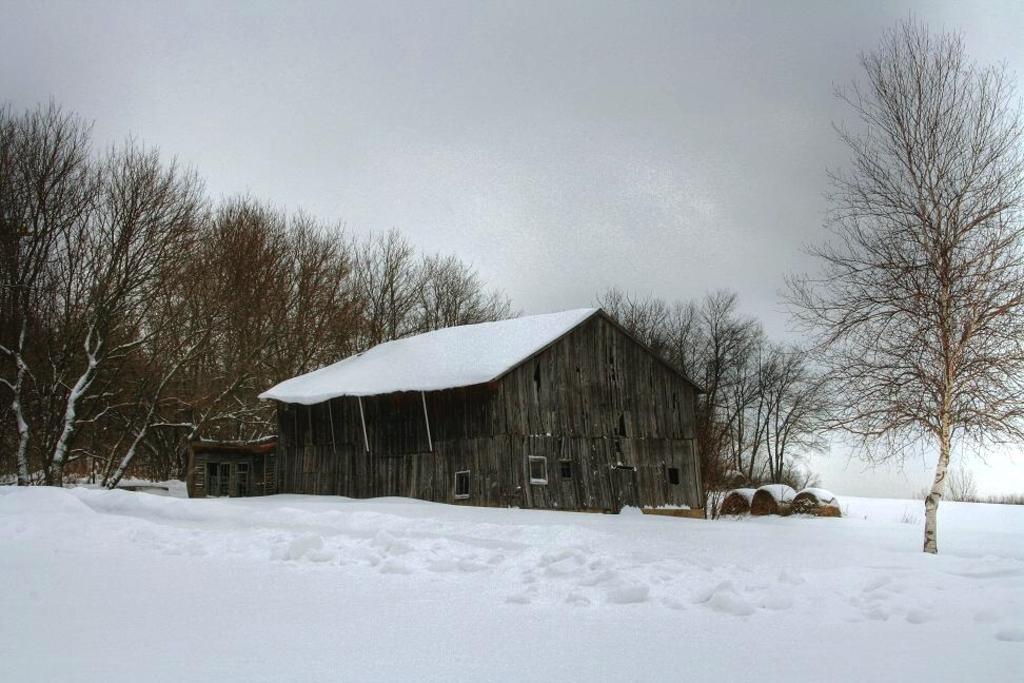Please provide a concise description of this image. In the image in the center we can see one house,wood wall,roof and few other objects. In the background we can see sky,clouds,trees and snow. 